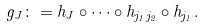Convert formula to latex. <formula><loc_0><loc_0><loc_500><loc_500>g _ { J } \colon = h _ { J } \circ \cdots \circ h _ { j _ { 1 } j _ { 2 } } \circ h _ { j _ { 1 } } .</formula> 